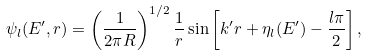<formula> <loc_0><loc_0><loc_500><loc_500>\psi _ { l } ( E ^ { \prime } , r ) = \left ( \frac { 1 } { 2 \pi R } \right ) ^ { 1 / 2 } \frac { 1 } { r } \sin \left [ k ^ { \prime } r + \eta _ { l } ( E ^ { \prime } ) - \frac { l \pi } { 2 } \right ] ,</formula> 